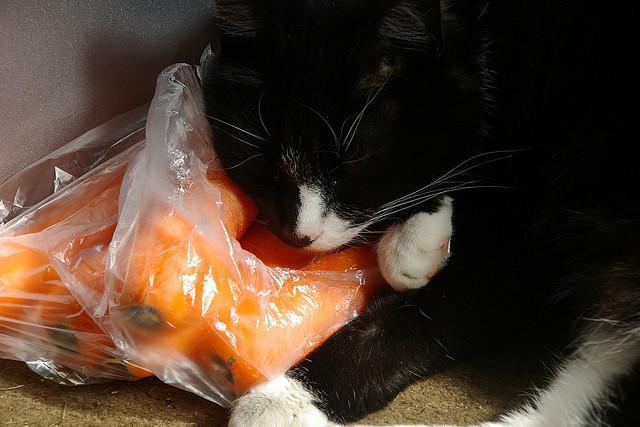How many carrots can be seen?
Give a very brief answer. 5. How many people are on the elephant on the right?
Give a very brief answer. 0. 